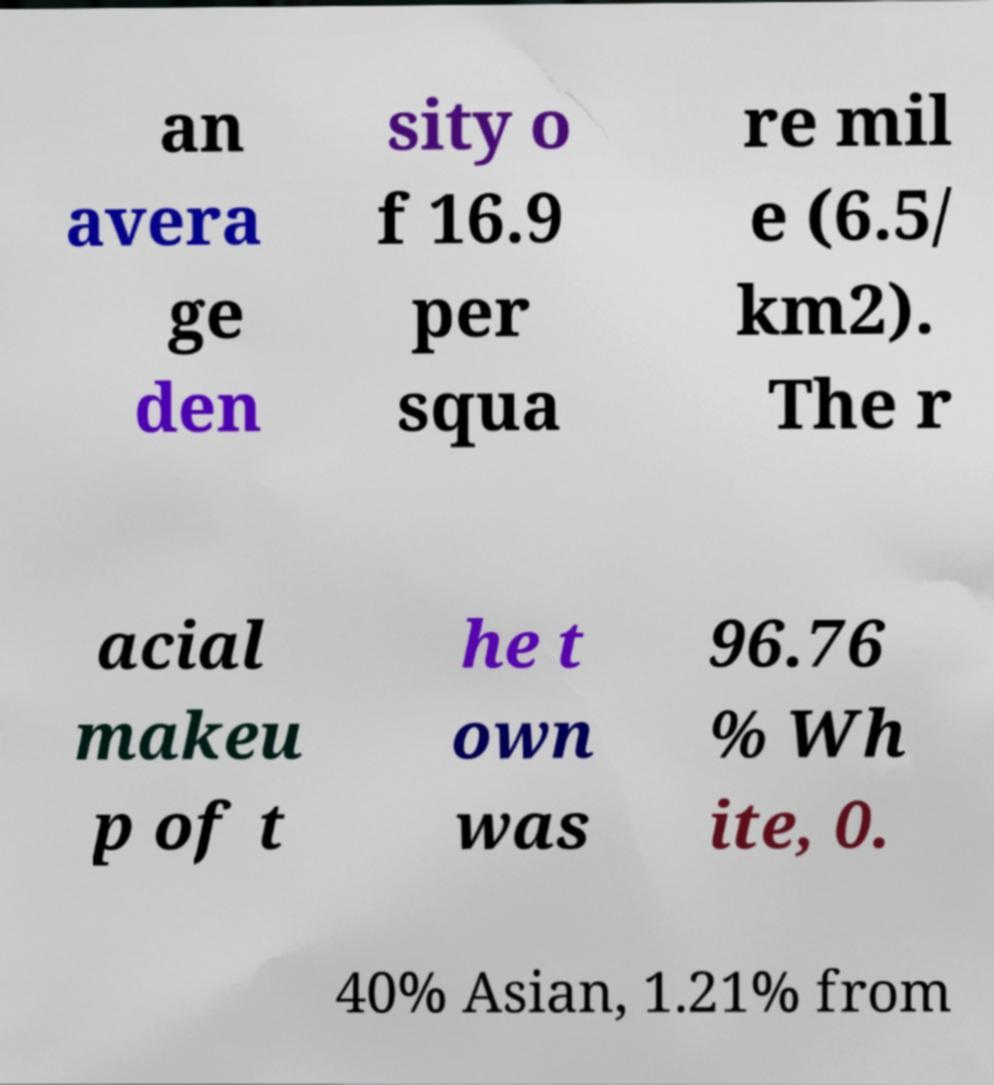Could you extract and type out the text from this image? an avera ge den sity o f 16.9 per squa re mil e (6.5/ km2). The r acial makeu p of t he t own was 96.76 % Wh ite, 0. 40% Asian, 1.21% from 